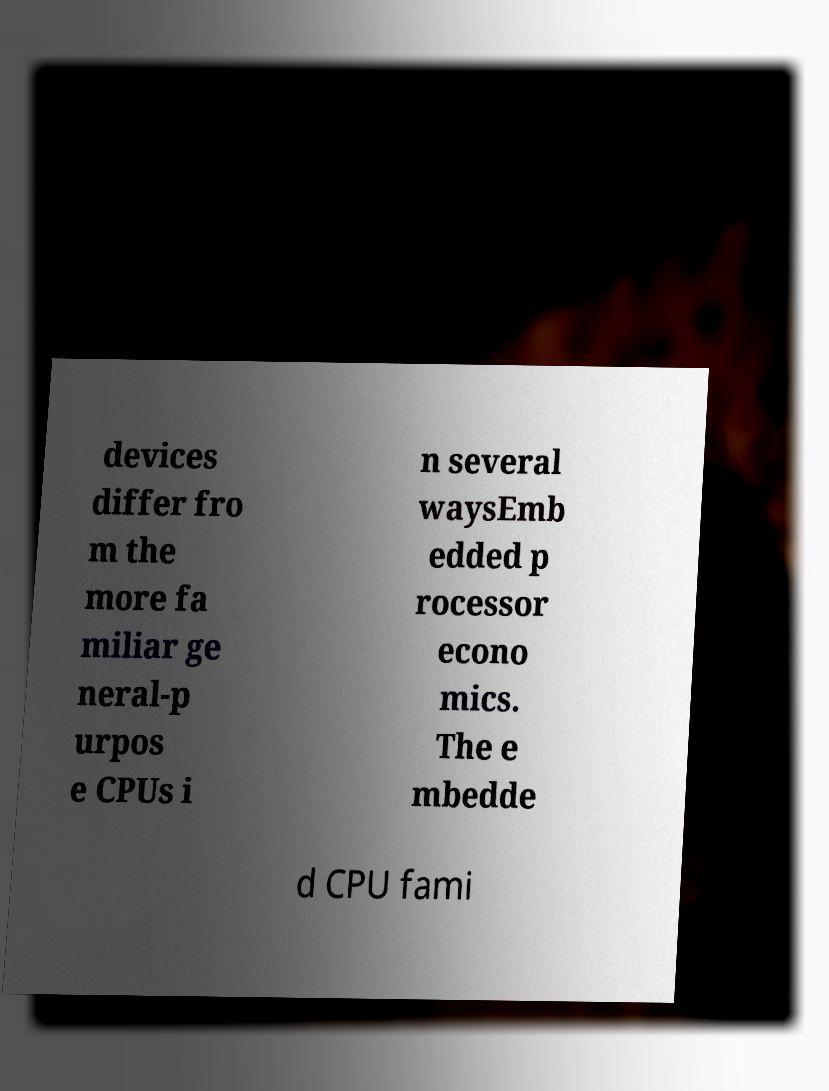Could you assist in decoding the text presented in this image and type it out clearly? devices differ fro m the more fa miliar ge neral-p urpos e CPUs i n several waysEmb edded p rocessor econo mics. The e mbedde d CPU fami 